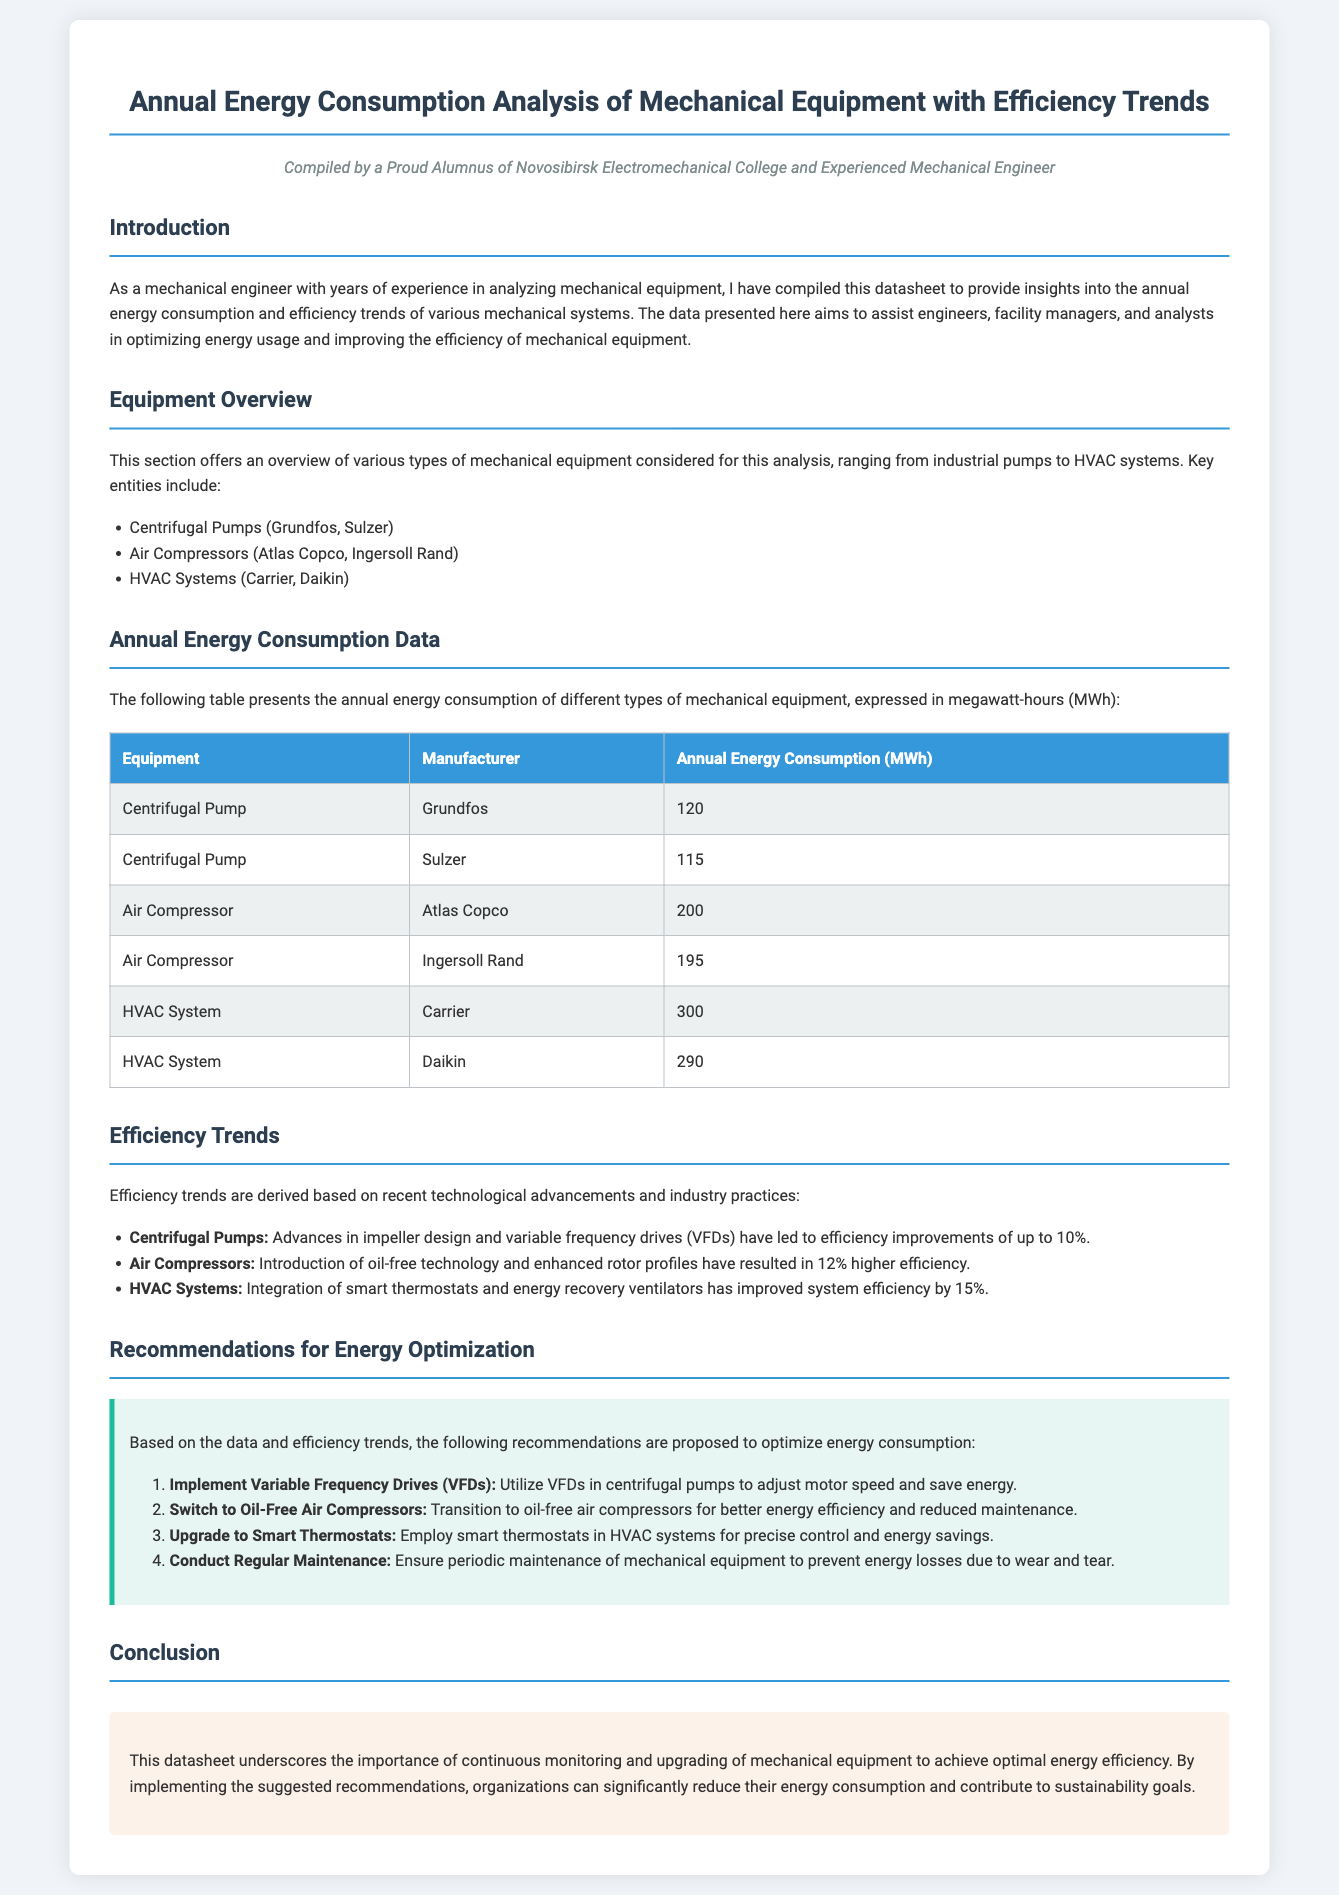What is the annual energy consumption of the Grundfos centrifugal pump? The table lists the annual energy consumption for Grundfos centrifugal pump as 120 MWh.
Answer: 120 MWh Which air compressor consumes the least energy? In the table, the Ingersoll Rand air compressor has the lowest annual energy consumption of 195 MWh.
Answer: Ingersoll Rand What efficiency improvement percentage is noted for HVAC systems? The document states that HVAC systems have improved efficiency by 15% due to technological advancements.
Answer: 15% What is the total annual energy consumption of HVAC systems combined? By adding the annual energy consumption of both HVAC systems (300 MWh + 290 MWh), the total is 590 MWh.
Answer: 590 MWh Which equipment type shows the highest annual energy consumption? The HVAC system has the highest annual energy consumption, listed at 300 MWh in the table.
Answer: HVAC System What is one recommendation to optimize energy consumption for air compressors? The document suggests transitioning to oil-free air compressors as a way to improve energy efficiency.
Answer: Switch to Oil-Free Air Compressors How many types of mechanical equipment are analyzed in the datasheet? The introduction mentions three categories of mechanical equipment: centrifugal pumps, air compressors, and HVAC systems.
Answer: Three What technology is recommended for centrifugal pumps to save energy? The datasheet recommends implementing variable frequency drives (VFDs) for centrifugal pumps to adjust motor speed and save energy.
Answer: Variable Frequency Drives (VFDs) 